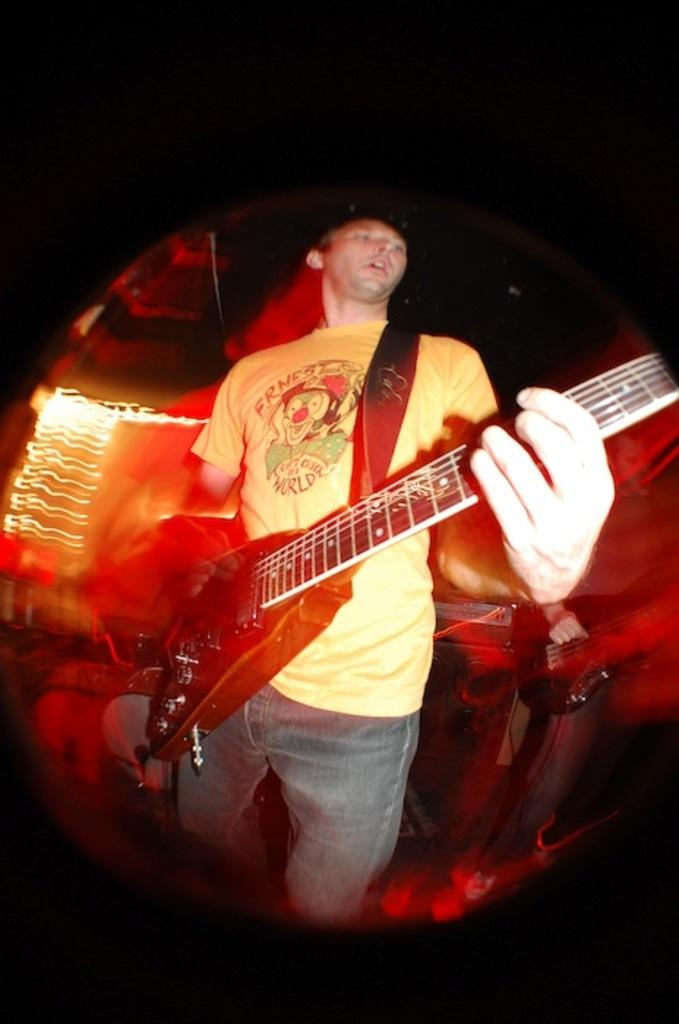What is the main subject of the image? There is a person in the image. What is the person doing in the image? The person is standing in the image. What object is the person holding in the image? The person is holding a guitar in the image. What is the texture of the moon in the image? There is no moon present in the image. What time of day is it in the image? The provided facts do not mention the time of day, so it cannot be determined from the image. 